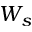<formula> <loc_0><loc_0><loc_500><loc_500>W _ { s }</formula> 